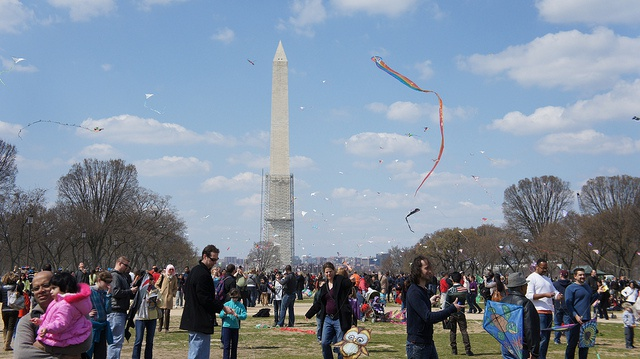Describe the objects in this image and their specific colors. I can see people in lightgray, black, gray, darkgray, and tan tones, people in lightgray, black, purple, violet, and maroon tones, people in lightgray, black, gray, and navy tones, people in lightgray, black, navy, and gray tones, and kite in lightgray, lightblue, and darkgray tones in this image. 